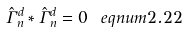<formula> <loc_0><loc_0><loc_500><loc_500>\hat { \Gamma } _ { n } ^ { d } * \hat { \Gamma } _ { n } ^ { d } = 0 \ e q n u m { 2 . 2 2 }</formula> 